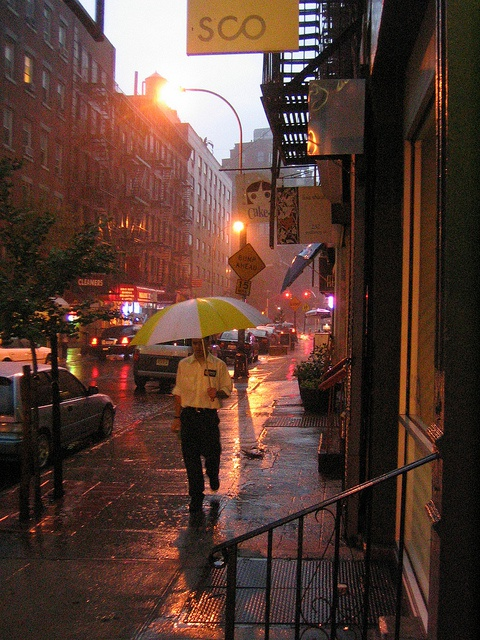Describe the objects in this image and their specific colors. I can see car in black, maroon, brown, and gray tones, people in black, brown, and maroon tones, umbrella in black, olive, and gray tones, car in black, maroon, gray, and brown tones, and car in black, maroon, gray, and brown tones in this image. 